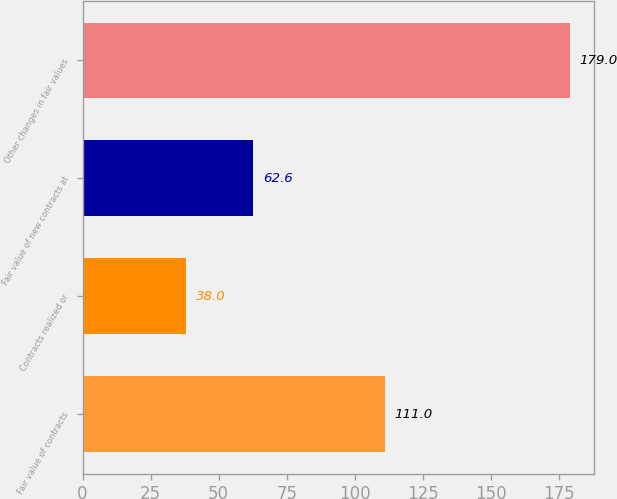Convert chart to OTSL. <chart><loc_0><loc_0><loc_500><loc_500><bar_chart><fcel>Fair value of contracts<fcel>Contracts realized or<fcel>Fair value of new contracts at<fcel>Other changes in fair values<nl><fcel>111<fcel>38<fcel>62.6<fcel>179<nl></chart> 